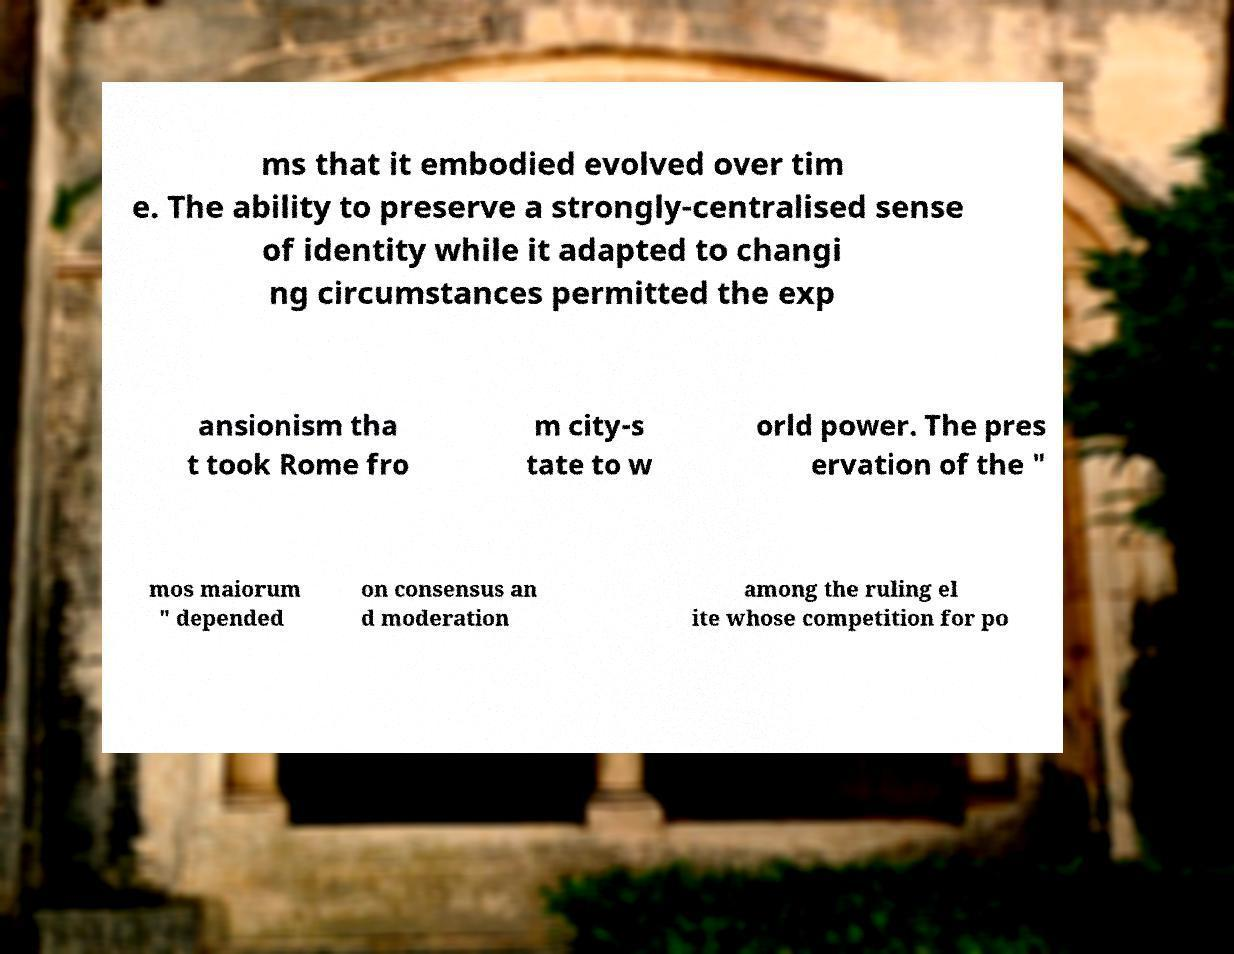There's text embedded in this image that I need extracted. Can you transcribe it verbatim? ms that it embodied evolved over tim e. The ability to preserve a strongly-centralised sense of identity while it adapted to changi ng circumstances permitted the exp ansionism tha t took Rome fro m city-s tate to w orld power. The pres ervation of the " mos maiorum " depended on consensus an d moderation among the ruling el ite whose competition for po 